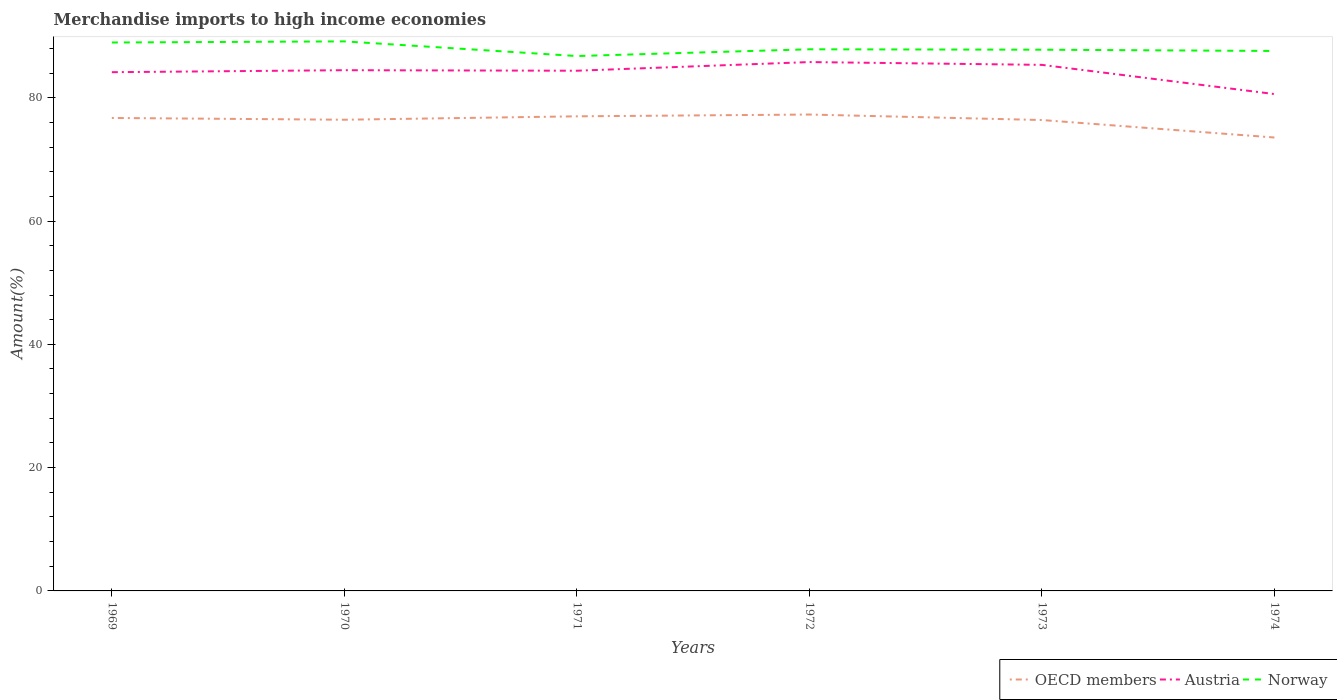How many different coloured lines are there?
Make the answer very short. 3. Is the number of lines equal to the number of legend labels?
Keep it short and to the point. Yes. Across all years, what is the maximum percentage of amount earned from merchandise imports in OECD members?
Your response must be concise. 73.55. In which year was the percentage of amount earned from merchandise imports in Norway maximum?
Make the answer very short. 1971. What is the total percentage of amount earned from merchandise imports in OECD members in the graph?
Your answer should be very brief. -0.27. What is the difference between the highest and the second highest percentage of amount earned from merchandise imports in Norway?
Ensure brevity in your answer.  2.38. How many lines are there?
Provide a short and direct response. 3. What is the difference between two consecutive major ticks on the Y-axis?
Offer a terse response. 20. Does the graph contain grids?
Your answer should be compact. No. Where does the legend appear in the graph?
Your answer should be very brief. Bottom right. How many legend labels are there?
Provide a short and direct response. 3. What is the title of the graph?
Your answer should be very brief. Merchandise imports to high income economies. Does "High income" appear as one of the legend labels in the graph?
Your answer should be compact. No. What is the label or title of the Y-axis?
Your answer should be compact. Amount(%). What is the Amount(%) in OECD members in 1969?
Your answer should be very brief. 76.72. What is the Amount(%) in Austria in 1969?
Your answer should be very brief. 84.15. What is the Amount(%) of Norway in 1969?
Keep it short and to the point. 88.96. What is the Amount(%) in OECD members in 1970?
Ensure brevity in your answer.  76.43. What is the Amount(%) in Austria in 1970?
Your answer should be very brief. 84.47. What is the Amount(%) in Norway in 1970?
Your answer should be compact. 89.14. What is the Amount(%) in OECD members in 1971?
Keep it short and to the point. 76.99. What is the Amount(%) of Austria in 1971?
Provide a short and direct response. 84.38. What is the Amount(%) of Norway in 1971?
Give a very brief answer. 86.76. What is the Amount(%) in OECD members in 1972?
Give a very brief answer. 77.28. What is the Amount(%) in Austria in 1972?
Give a very brief answer. 85.79. What is the Amount(%) in Norway in 1972?
Provide a succinct answer. 87.86. What is the Amount(%) in OECD members in 1973?
Provide a succinct answer. 76.39. What is the Amount(%) in Austria in 1973?
Give a very brief answer. 85.33. What is the Amount(%) of Norway in 1973?
Ensure brevity in your answer.  87.79. What is the Amount(%) in OECD members in 1974?
Provide a short and direct response. 73.55. What is the Amount(%) of Austria in 1974?
Provide a succinct answer. 80.6. What is the Amount(%) of Norway in 1974?
Ensure brevity in your answer.  87.59. Across all years, what is the maximum Amount(%) of OECD members?
Provide a short and direct response. 77.28. Across all years, what is the maximum Amount(%) in Austria?
Your answer should be very brief. 85.79. Across all years, what is the maximum Amount(%) of Norway?
Make the answer very short. 89.14. Across all years, what is the minimum Amount(%) of OECD members?
Keep it short and to the point. 73.55. Across all years, what is the minimum Amount(%) in Austria?
Provide a succinct answer. 80.6. Across all years, what is the minimum Amount(%) of Norway?
Your answer should be very brief. 86.76. What is the total Amount(%) in OECD members in the graph?
Your answer should be very brief. 457.36. What is the total Amount(%) in Austria in the graph?
Give a very brief answer. 504.72. What is the total Amount(%) of Norway in the graph?
Offer a terse response. 528.11. What is the difference between the Amount(%) in OECD members in 1969 and that in 1970?
Your response must be concise. 0.29. What is the difference between the Amount(%) in Austria in 1969 and that in 1970?
Give a very brief answer. -0.32. What is the difference between the Amount(%) of Norway in 1969 and that in 1970?
Your answer should be compact. -0.18. What is the difference between the Amount(%) of OECD members in 1969 and that in 1971?
Keep it short and to the point. -0.27. What is the difference between the Amount(%) in Austria in 1969 and that in 1971?
Your answer should be compact. -0.24. What is the difference between the Amount(%) of Norway in 1969 and that in 1971?
Offer a terse response. 2.2. What is the difference between the Amount(%) of OECD members in 1969 and that in 1972?
Give a very brief answer. -0.56. What is the difference between the Amount(%) of Austria in 1969 and that in 1972?
Offer a very short reply. -1.64. What is the difference between the Amount(%) in Norway in 1969 and that in 1972?
Your answer should be compact. 1.1. What is the difference between the Amount(%) of OECD members in 1969 and that in 1973?
Ensure brevity in your answer.  0.33. What is the difference between the Amount(%) of Austria in 1969 and that in 1973?
Your answer should be very brief. -1.19. What is the difference between the Amount(%) of Norway in 1969 and that in 1973?
Offer a terse response. 1.17. What is the difference between the Amount(%) in OECD members in 1969 and that in 1974?
Keep it short and to the point. 3.17. What is the difference between the Amount(%) in Austria in 1969 and that in 1974?
Offer a very short reply. 3.55. What is the difference between the Amount(%) in Norway in 1969 and that in 1974?
Your response must be concise. 1.37. What is the difference between the Amount(%) of OECD members in 1970 and that in 1971?
Offer a terse response. -0.55. What is the difference between the Amount(%) in Austria in 1970 and that in 1971?
Keep it short and to the point. 0.09. What is the difference between the Amount(%) of Norway in 1970 and that in 1971?
Give a very brief answer. 2.38. What is the difference between the Amount(%) in OECD members in 1970 and that in 1972?
Offer a terse response. -0.84. What is the difference between the Amount(%) in Austria in 1970 and that in 1972?
Provide a short and direct response. -1.32. What is the difference between the Amount(%) in Norway in 1970 and that in 1972?
Offer a very short reply. 1.28. What is the difference between the Amount(%) of OECD members in 1970 and that in 1973?
Give a very brief answer. 0.05. What is the difference between the Amount(%) of Austria in 1970 and that in 1973?
Provide a succinct answer. -0.87. What is the difference between the Amount(%) of Norway in 1970 and that in 1973?
Give a very brief answer. 1.35. What is the difference between the Amount(%) in OECD members in 1970 and that in 1974?
Keep it short and to the point. 2.88. What is the difference between the Amount(%) in Austria in 1970 and that in 1974?
Your response must be concise. 3.87. What is the difference between the Amount(%) of Norway in 1970 and that in 1974?
Provide a short and direct response. 1.56. What is the difference between the Amount(%) in OECD members in 1971 and that in 1972?
Offer a terse response. -0.29. What is the difference between the Amount(%) of Austria in 1971 and that in 1972?
Offer a very short reply. -1.41. What is the difference between the Amount(%) of Norway in 1971 and that in 1972?
Your response must be concise. -1.09. What is the difference between the Amount(%) in OECD members in 1971 and that in 1973?
Your answer should be very brief. 0.6. What is the difference between the Amount(%) in Austria in 1971 and that in 1973?
Your answer should be very brief. -0.95. What is the difference between the Amount(%) in Norway in 1971 and that in 1973?
Your answer should be compact. -1.03. What is the difference between the Amount(%) of OECD members in 1971 and that in 1974?
Offer a terse response. 3.44. What is the difference between the Amount(%) in Austria in 1971 and that in 1974?
Ensure brevity in your answer.  3.78. What is the difference between the Amount(%) in Norway in 1971 and that in 1974?
Offer a very short reply. -0.82. What is the difference between the Amount(%) in OECD members in 1972 and that in 1973?
Make the answer very short. 0.89. What is the difference between the Amount(%) in Austria in 1972 and that in 1973?
Keep it short and to the point. 0.45. What is the difference between the Amount(%) of Norway in 1972 and that in 1973?
Give a very brief answer. 0.07. What is the difference between the Amount(%) of OECD members in 1972 and that in 1974?
Your answer should be compact. 3.73. What is the difference between the Amount(%) of Austria in 1972 and that in 1974?
Ensure brevity in your answer.  5.19. What is the difference between the Amount(%) in Norway in 1972 and that in 1974?
Keep it short and to the point. 0.27. What is the difference between the Amount(%) of OECD members in 1973 and that in 1974?
Ensure brevity in your answer.  2.83. What is the difference between the Amount(%) in Austria in 1973 and that in 1974?
Give a very brief answer. 4.74. What is the difference between the Amount(%) of Norway in 1973 and that in 1974?
Your answer should be compact. 0.2. What is the difference between the Amount(%) of OECD members in 1969 and the Amount(%) of Austria in 1970?
Make the answer very short. -7.75. What is the difference between the Amount(%) in OECD members in 1969 and the Amount(%) in Norway in 1970?
Your answer should be very brief. -12.42. What is the difference between the Amount(%) of Austria in 1969 and the Amount(%) of Norway in 1970?
Your answer should be compact. -5. What is the difference between the Amount(%) in OECD members in 1969 and the Amount(%) in Austria in 1971?
Ensure brevity in your answer.  -7.66. What is the difference between the Amount(%) in OECD members in 1969 and the Amount(%) in Norway in 1971?
Provide a succinct answer. -10.04. What is the difference between the Amount(%) in Austria in 1969 and the Amount(%) in Norway in 1971?
Give a very brief answer. -2.62. What is the difference between the Amount(%) of OECD members in 1969 and the Amount(%) of Austria in 1972?
Keep it short and to the point. -9.07. What is the difference between the Amount(%) of OECD members in 1969 and the Amount(%) of Norway in 1972?
Ensure brevity in your answer.  -11.14. What is the difference between the Amount(%) of Austria in 1969 and the Amount(%) of Norway in 1972?
Provide a short and direct response. -3.71. What is the difference between the Amount(%) in OECD members in 1969 and the Amount(%) in Austria in 1973?
Offer a very short reply. -8.61. What is the difference between the Amount(%) of OECD members in 1969 and the Amount(%) of Norway in 1973?
Your answer should be very brief. -11.07. What is the difference between the Amount(%) of Austria in 1969 and the Amount(%) of Norway in 1973?
Ensure brevity in your answer.  -3.65. What is the difference between the Amount(%) of OECD members in 1969 and the Amount(%) of Austria in 1974?
Offer a very short reply. -3.88. What is the difference between the Amount(%) of OECD members in 1969 and the Amount(%) of Norway in 1974?
Your response must be concise. -10.87. What is the difference between the Amount(%) in Austria in 1969 and the Amount(%) in Norway in 1974?
Give a very brief answer. -3.44. What is the difference between the Amount(%) in OECD members in 1970 and the Amount(%) in Austria in 1971?
Give a very brief answer. -7.95. What is the difference between the Amount(%) in OECD members in 1970 and the Amount(%) in Norway in 1971?
Provide a short and direct response. -10.33. What is the difference between the Amount(%) of Austria in 1970 and the Amount(%) of Norway in 1971?
Keep it short and to the point. -2.3. What is the difference between the Amount(%) of OECD members in 1970 and the Amount(%) of Austria in 1972?
Give a very brief answer. -9.35. What is the difference between the Amount(%) of OECD members in 1970 and the Amount(%) of Norway in 1972?
Offer a terse response. -11.42. What is the difference between the Amount(%) in Austria in 1970 and the Amount(%) in Norway in 1972?
Your answer should be very brief. -3.39. What is the difference between the Amount(%) in OECD members in 1970 and the Amount(%) in Austria in 1973?
Provide a succinct answer. -8.9. What is the difference between the Amount(%) of OECD members in 1970 and the Amount(%) of Norway in 1973?
Your answer should be compact. -11.36. What is the difference between the Amount(%) of Austria in 1970 and the Amount(%) of Norway in 1973?
Give a very brief answer. -3.32. What is the difference between the Amount(%) of OECD members in 1970 and the Amount(%) of Austria in 1974?
Give a very brief answer. -4.16. What is the difference between the Amount(%) in OECD members in 1970 and the Amount(%) in Norway in 1974?
Ensure brevity in your answer.  -11.15. What is the difference between the Amount(%) in Austria in 1970 and the Amount(%) in Norway in 1974?
Give a very brief answer. -3.12. What is the difference between the Amount(%) in OECD members in 1971 and the Amount(%) in Austria in 1972?
Ensure brevity in your answer.  -8.8. What is the difference between the Amount(%) in OECD members in 1971 and the Amount(%) in Norway in 1972?
Ensure brevity in your answer.  -10.87. What is the difference between the Amount(%) in Austria in 1971 and the Amount(%) in Norway in 1972?
Provide a short and direct response. -3.48. What is the difference between the Amount(%) of OECD members in 1971 and the Amount(%) of Austria in 1973?
Provide a short and direct response. -8.35. What is the difference between the Amount(%) of OECD members in 1971 and the Amount(%) of Norway in 1973?
Give a very brief answer. -10.81. What is the difference between the Amount(%) in Austria in 1971 and the Amount(%) in Norway in 1973?
Offer a very short reply. -3.41. What is the difference between the Amount(%) of OECD members in 1971 and the Amount(%) of Austria in 1974?
Keep it short and to the point. -3.61. What is the difference between the Amount(%) of OECD members in 1971 and the Amount(%) of Norway in 1974?
Provide a short and direct response. -10.6. What is the difference between the Amount(%) of Austria in 1971 and the Amount(%) of Norway in 1974?
Your answer should be very brief. -3.21. What is the difference between the Amount(%) in OECD members in 1972 and the Amount(%) in Austria in 1973?
Make the answer very short. -8.06. What is the difference between the Amount(%) in OECD members in 1972 and the Amount(%) in Norway in 1973?
Make the answer very short. -10.52. What is the difference between the Amount(%) in Austria in 1972 and the Amount(%) in Norway in 1973?
Provide a succinct answer. -2. What is the difference between the Amount(%) in OECD members in 1972 and the Amount(%) in Austria in 1974?
Your response must be concise. -3.32. What is the difference between the Amount(%) of OECD members in 1972 and the Amount(%) of Norway in 1974?
Provide a short and direct response. -10.31. What is the difference between the Amount(%) in Austria in 1972 and the Amount(%) in Norway in 1974?
Provide a short and direct response. -1.8. What is the difference between the Amount(%) of OECD members in 1973 and the Amount(%) of Austria in 1974?
Provide a succinct answer. -4.21. What is the difference between the Amount(%) of OECD members in 1973 and the Amount(%) of Norway in 1974?
Offer a very short reply. -11.2. What is the difference between the Amount(%) in Austria in 1973 and the Amount(%) in Norway in 1974?
Ensure brevity in your answer.  -2.25. What is the average Amount(%) in OECD members per year?
Provide a short and direct response. 76.23. What is the average Amount(%) of Austria per year?
Your answer should be very brief. 84.12. What is the average Amount(%) in Norway per year?
Provide a short and direct response. 88.02. In the year 1969, what is the difference between the Amount(%) of OECD members and Amount(%) of Austria?
Offer a terse response. -7.43. In the year 1969, what is the difference between the Amount(%) in OECD members and Amount(%) in Norway?
Provide a succinct answer. -12.24. In the year 1969, what is the difference between the Amount(%) in Austria and Amount(%) in Norway?
Your answer should be very brief. -4.81. In the year 1970, what is the difference between the Amount(%) in OECD members and Amount(%) in Austria?
Give a very brief answer. -8.03. In the year 1970, what is the difference between the Amount(%) in OECD members and Amount(%) in Norway?
Ensure brevity in your answer.  -12.71. In the year 1970, what is the difference between the Amount(%) in Austria and Amount(%) in Norway?
Provide a short and direct response. -4.67. In the year 1971, what is the difference between the Amount(%) of OECD members and Amount(%) of Austria?
Offer a very short reply. -7.4. In the year 1971, what is the difference between the Amount(%) of OECD members and Amount(%) of Norway?
Offer a very short reply. -9.78. In the year 1971, what is the difference between the Amount(%) of Austria and Amount(%) of Norway?
Provide a succinct answer. -2.38. In the year 1972, what is the difference between the Amount(%) in OECD members and Amount(%) in Austria?
Your answer should be compact. -8.51. In the year 1972, what is the difference between the Amount(%) in OECD members and Amount(%) in Norway?
Your answer should be very brief. -10.58. In the year 1972, what is the difference between the Amount(%) of Austria and Amount(%) of Norway?
Ensure brevity in your answer.  -2.07. In the year 1973, what is the difference between the Amount(%) in OECD members and Amount(%) in Austria?
Your answer should be very brief. -8.95. In the year 1973, what is the difference between the Amount(%) in OECD members and Amount(%) in Norway?
Ensure brevity in your answer.  -11.41. In the year 1973, what is the difference between the Amount(%) in Austria and Amount(%) in Norway?
Keep it short and to the point. -2.46. In the year 1974, what is the difference between the Amount(%) in OECD members and Amount(%) in Austria?
Offer a terse response. -7.05. In the year 1974, what is the difference between the Amount(%) of OECD members and Amount(%) of Norway?
Make the answer very short. -14.04. In the year 1974, what is the difference between the Amount(%) of Austria and Amount(%) of Norway?
Ensure brevity in your answer.  -6.99. What is the ratio of the Amount(%) in Austria in 1969 to that in 1970?
Make the answer very short. 1. What is the ratio of the Amount(%) in Austria in 1969 to that in 1971?
Provide a succinct answer. 1. What is the ratio of the Amount(%) of Norway in 1969 to that in 1971?
Offer a very short reply. 1.03. What is the ratio of the Amount(%) in Austria in 1969 to that in 1972?
Offer a very short reply. 0.98. What is the ratio of the Amount(%) in Norway in 1969 to that in 1972?
Offer a very short reply. 1.01. What is the ratio of the Amount(%) of Austria in 1969 to that in 1973?
Your response must be concise. 0.99. What is the ratio of the Amount(%) of Norway in 1969 to that in 1973?
Offer a terse response. 1.01. What is the ratio of the Amount(%) in OECD members in 1969 to that in 1974?
Provide a short and direct response. 1.04. What is the ratio of the Amount(%) of Austria in 1969 to that in 1974?
Your answer should be very brief. 1.04. What is the ratio of the Amount(%) in Norway in 1969 to that in 1974?
Give a very brief answer. 1.02. What is the ratio of the Amount(%) in Austria in 1970 to that in 1971?
Offer a terse response. 1. What is the ratio of the Amount(%) of Norway in 1970 to that in 1971?
Ensure brevity in your answer.  1.03. What is the ratio of the Amount(%) of OECD members in 1970 to that in 1972?
Keep it short and to the point. 0.99. What is the ratio of the Amount(%) of Austria in 1970 to that in 1972?
Offer a very short reply. 0.98. What is the ratio of the Amount(%) in Norway in 1970 to that in 1972?
Provide a succinct answer. 1.01. What is the ratio of the Amount(%) of Austria in 1970 to that in 1973?
Your answer should be very brief. 0.99. What is the ratio of the Amount(%) in Norway in 1970 to that in 1973?
Your answer should be very brief. 1.02. What is the ratio of the Amount(%) in OECD members in 1970 to that in 1974?
Keep it short and to the point. 1.04. What is the ratio of the Amount(%) of Austria in 1970 to that in 1974?
Your answer should be compact. 1.05. What is the ratio of the Amount(%) of Norway in 1970 to that in 1974?
Your response must be concise. 1.02. What is the ratio of the Amount(%) of OECD members in 1971 to that in 1972?
Give a very brief answer. 1. What is the ratio of the Amount(%) in Austria in 1971 to that in 1972?
Keep it short and to the point. 0.98. What is the ratio of the Amount(%) of Norway in 1971 to that in 1972?
Provide a succinct answer. 0.99. What is the ratio of the Amount(%) of OECD members in 1971 to that in 1973?
Ensure brevity in your answer.  1.01. What is the ratio of the Amount(%) in Austria in 1971 to that in 1973?
Provide a short and direct response. 0.99. What is the ratio of the Amount(%) in Norway in 1971 to that in 1973?
Ensure brevity in your answer.  0.99. What is the ratio of the Amount(%) of OECD members in 1971 to that in 1974?
Provide a short and direct response. 1.05. What is the ratio of the Amount(%) of Austria in 1971 to that in 1974?
Ensure brevity in your answer.  1.05. What is the ratio of the Amount(%) of Norway in 1971 to that in 1974?
Ensure brevity in your answer.  0.99. What is the ratio of the Amount(%) of OECD members in 1972 to that in 1973?
Provide a short and direct response. 1.01. What is the ratio of the Amount(%) of Austria in 1972 to that in 1973?
Offer a very short reply. 1.01. What is the ratio of the Amount(%) of OECD members in 1972 to that in 1974?
Offer a very short reply. 1.05. What is the ratio of the Amount(%) in Austria in 1972 to that in 1974?
Keep it short and to the point. 1.06. What is the ratio of the Amount(%) in Austria in 1973 to that in 1974?
Offer a terse response. 1.06. What is the ratio of the Amount(%) in Norway in 1973 to that in 1974?
Provide a short and direct response. 1. What is the difference between the highest and the second highest Amount(%) of OECD members?
Make the answer very short. 0.29. What is the difference between the highest and the second highest Amount(%) of Austria?
Your answer should be compact. 0.45. What is the difference between the highest and the second highest Amount(%) in Norway?
Offer a terse response. 0.18. What is the difference between the highest and the lowest Amount(%) in OECD members?
Offer a terse response. 3.73. What is the difference between the highest and the lowest Amount(%) in Austria?
Offer a very short reply. 5.19. What is the difference between the highest and the lowest Amount(%) of Norway?
Offer a very short reply. 2.38. 